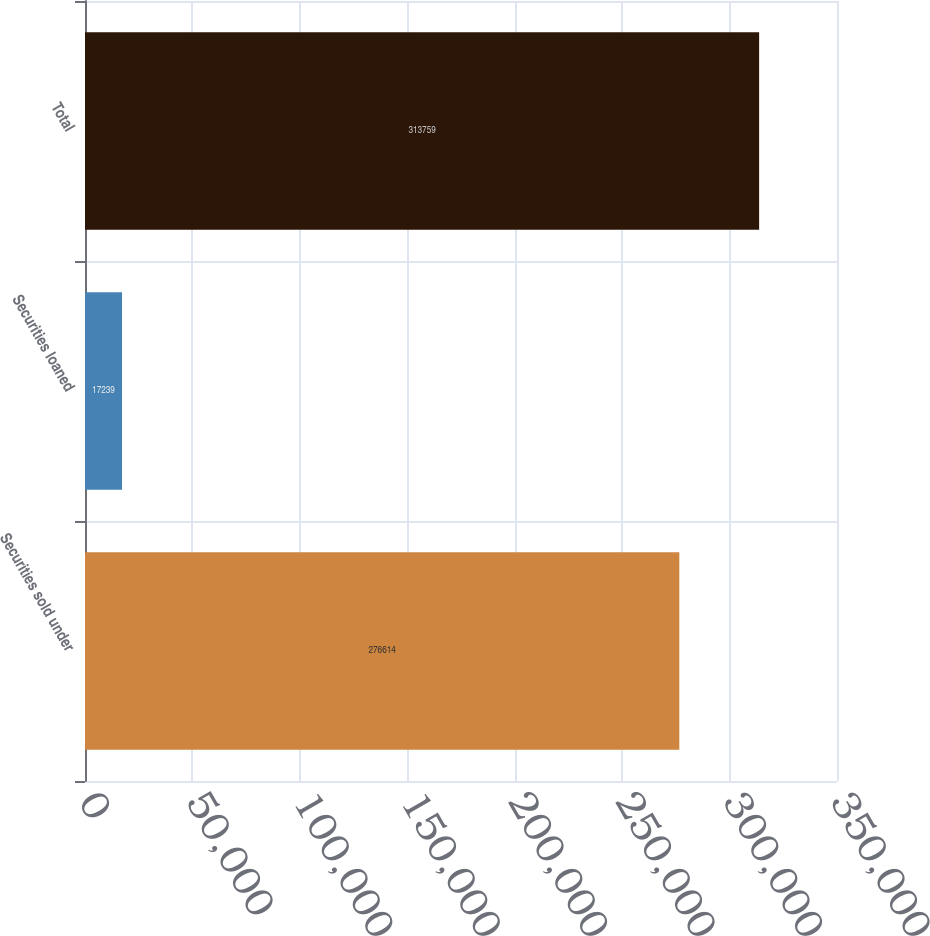Convert chart to OTSL. <chart><loc_0><loc_0><loc_500><loc_500><bar_chart><fcel>Securities sold under<fcel>Securities loaned<fcel>Total<nl><fcel>276614<fcel>17239<fcel>313759<nl></chart> 